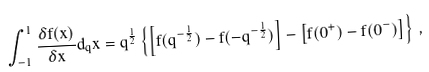Convert formula to latex. <formula><loc_0><loc_0><loc_500><loc_500>\int _ { - 1 } ^ { 1 } \frac { \delta f ( x ) } { \delta x } d _ { q } x = q ^ { \frac { 1 } { 2 } } \left \{ \left [ f ( q ^ { - \frac { 1 } { 2 } } ) - f ( - q ^ { - \frac { 1 } { 2 } } ) \right ] - \left [ f ( 0 ^ { + } ) - f ( 0 ^ { - } ) \right ] \right \} \, ,</formula> 